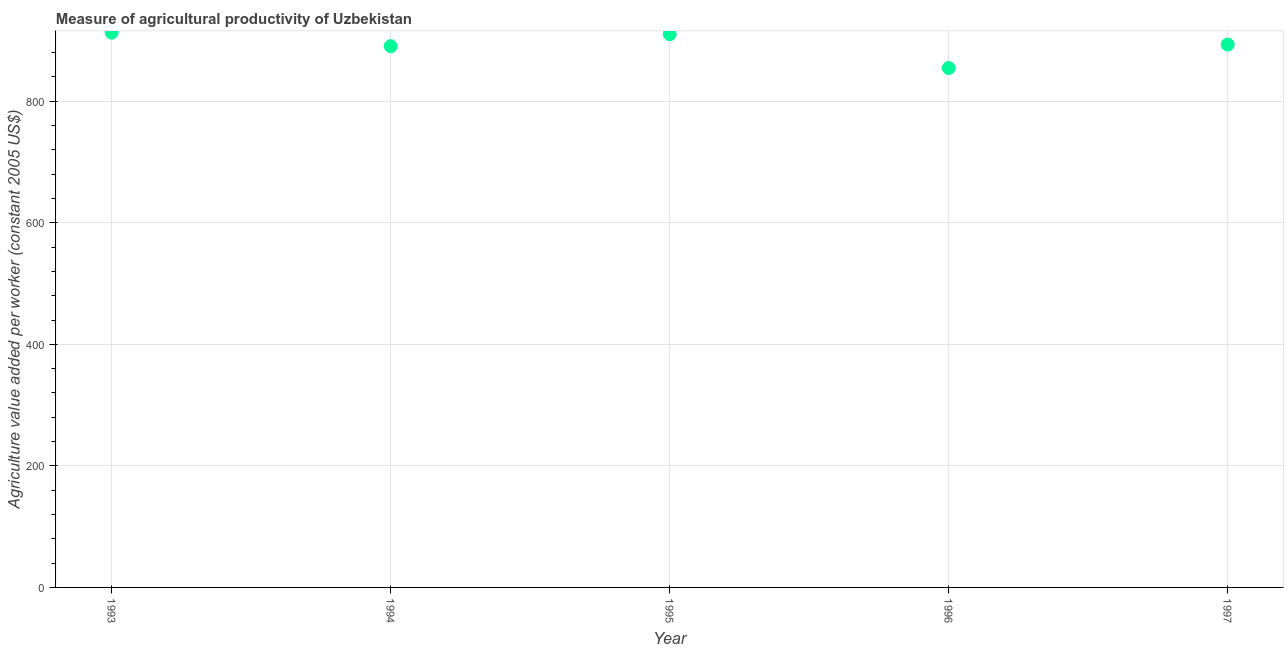What is the agriculture value added per worker in 1997?
Ensure brevity in your answer.  893.23. Across all years, what is the maximum agriculture value added per worker?
Give a very brief answer. 912.91. Across all years, what is the minimum agriculture value added per worker?
Provide a succinct answer. 854.6. In which year was the agriculture value added per worker maximum?
Offer a terse response. 1993. In which year was the agriculture value added per worker minimum?
Provide a short and direct response. 1996. What is the sum of the agriculture value added per worker?
Make the answer very short. 4461.53. What is the difference between the agriculture value added per worker in 1993 and 1996?
Keep it short and to the point. 58.31. What is the average agriculture value added per worker per year?
Provide a short and direct response. 892.31. What is the median agriculture value added per worker?
Make the answer very short. 893.23. What is the ratio of the agriculture value added per worker in 1993 to that in 1997?
Offer a terse response. 1.02. Is the agriculture value added per worker in 1993 less than that in 1995?
Provide a succinct answer. No. What is the difference between the highest and the second highest agriculture value added per worker?
Provide a succinct answer. 2.7. Is the sum of the agriculture value added per worker in 1996 and 1997 greater than the maximum agriculture value added per worker across all years?
Offer a terse response. Yes. What is the difference between the highest and the lowest agriculture value added per worker?
Provide a succinct answer. 58.31. How many dotlines are there?
Keep it short and to the point. 1. Are the values on the major ticks of Y-axis written in scientific E-notation?
Your answer should be compact. No. Does the graph contain any zero values?
Provide a succinct answer. No. Does the graph contain grids?
Your answer should be compact. Yes. What is the title of the graph?
Provide a short and direct response. Measure of agricultural productivity of Uzbekistan. What is the label or title of the X-axis?
Provide a short and direct response. Year. What is the label or title of the Y-axis?
Provide a short and direct response. Agriculture value added per worker (constant 2005 US$). What is the Agriculture value added per worker (constant 2005 US$) in 1993?
Your answer should be very brief. 912.91. What is the Agriculture value added per worker (constant 2005 US$) in 1994?
Keep it short and to the point. 890.59. What is the Agriculture value added per worker (constant 2005 US$) in 1995?
Give a very brief answer. 910.2. What is the Agriculture value added per worker (constant 2005 US$) in 1996?
Your response must be concise. 854.6. What is the Agriculture value added per worker (constant 2005 US$) in 1997?
Offer a very short reply. 893.23. What is the difference between the Agriculture value added per worker (constant 2005 US$) in 1993 and 1994?
Offer a very short reply. 22.31. What is the difference between the Agriculture value added per worker (constant 2005 US$) in 1993 and 1995?
Offer a terse response. 2.7. What is the difference between the Agriculture value added per worker (constant 2005 US$) in 1993 and 1996?
Make the answer very short. 58.31. What is the difference between the Agriculture value added per worker (constant 2005 US$) in 1993 and 1997?
Provide a short and direct response. 19.68. What is the difference between the Agriculture value added per worker (constant 2005 US$) in 1994 and 1995?
Offer a very short reply. -19.61. What is the difference between the Agriculture value added per worker (constant 2005 US$) in 1994 and 1996?
Your response must be concise. 36. What is the difference between the Agriculture value added per worker (constant 2005 US$) in 1994 and 1997?
Your answer should be compact. -2.64. What is the difference between the Agriculture value added per worker (constant 2005 US$) in 1995 and 1996?
Offer a terse response. 55.61. What is the difference between the Agriculture value added per worker (constant 2005 US$) in 1995 and 1997?
Offer a terse response. 16.97. What is the difference between the Agriculture value added per worker (constant 2005 US$) in 1996 and 1997?
Your answer should be very brief. -38.63. What is the ratio of the Agriculture value added per worker (constant 2005 US$) in 1993 to that in 1995?
Your response must be concise. 1. What is the ratio of the Agriculture value added per worker (constant 2005 US$) in 1993 to that in 1996?
Your answer should be very brief. 1.07. What is the ratio of the Agriculture value added per worker (constant 2005 US$) in 1993 to that in 1997?
Keep it short and to the point. 1.02. What is the ratio of the Agriculture value added per worker (constant 2005 US$) in 1994 to that in 1995?
Provide a succinct answer. 0.98. What is the ratio of the Agriculture value added per worker (constant 2005 US$) in 1994 to that in 1996?
Provide a short and direct response. 1.04. What is the ratio of the Agriculture value added per worker (constant 2005 US$) in 1995 to that in 1996?
Your response must be concise. 1.06. What is the ratio of the Agriculture value added per worker (constant 2005 US$) in 1995 to that in 1997?
Your response must be concise. 1.02. What is the ratio of the Agriculture value added per worker (constant 2005 US$) in 1996 to that in 1997?
Provide a succinct answer. 0.96. 